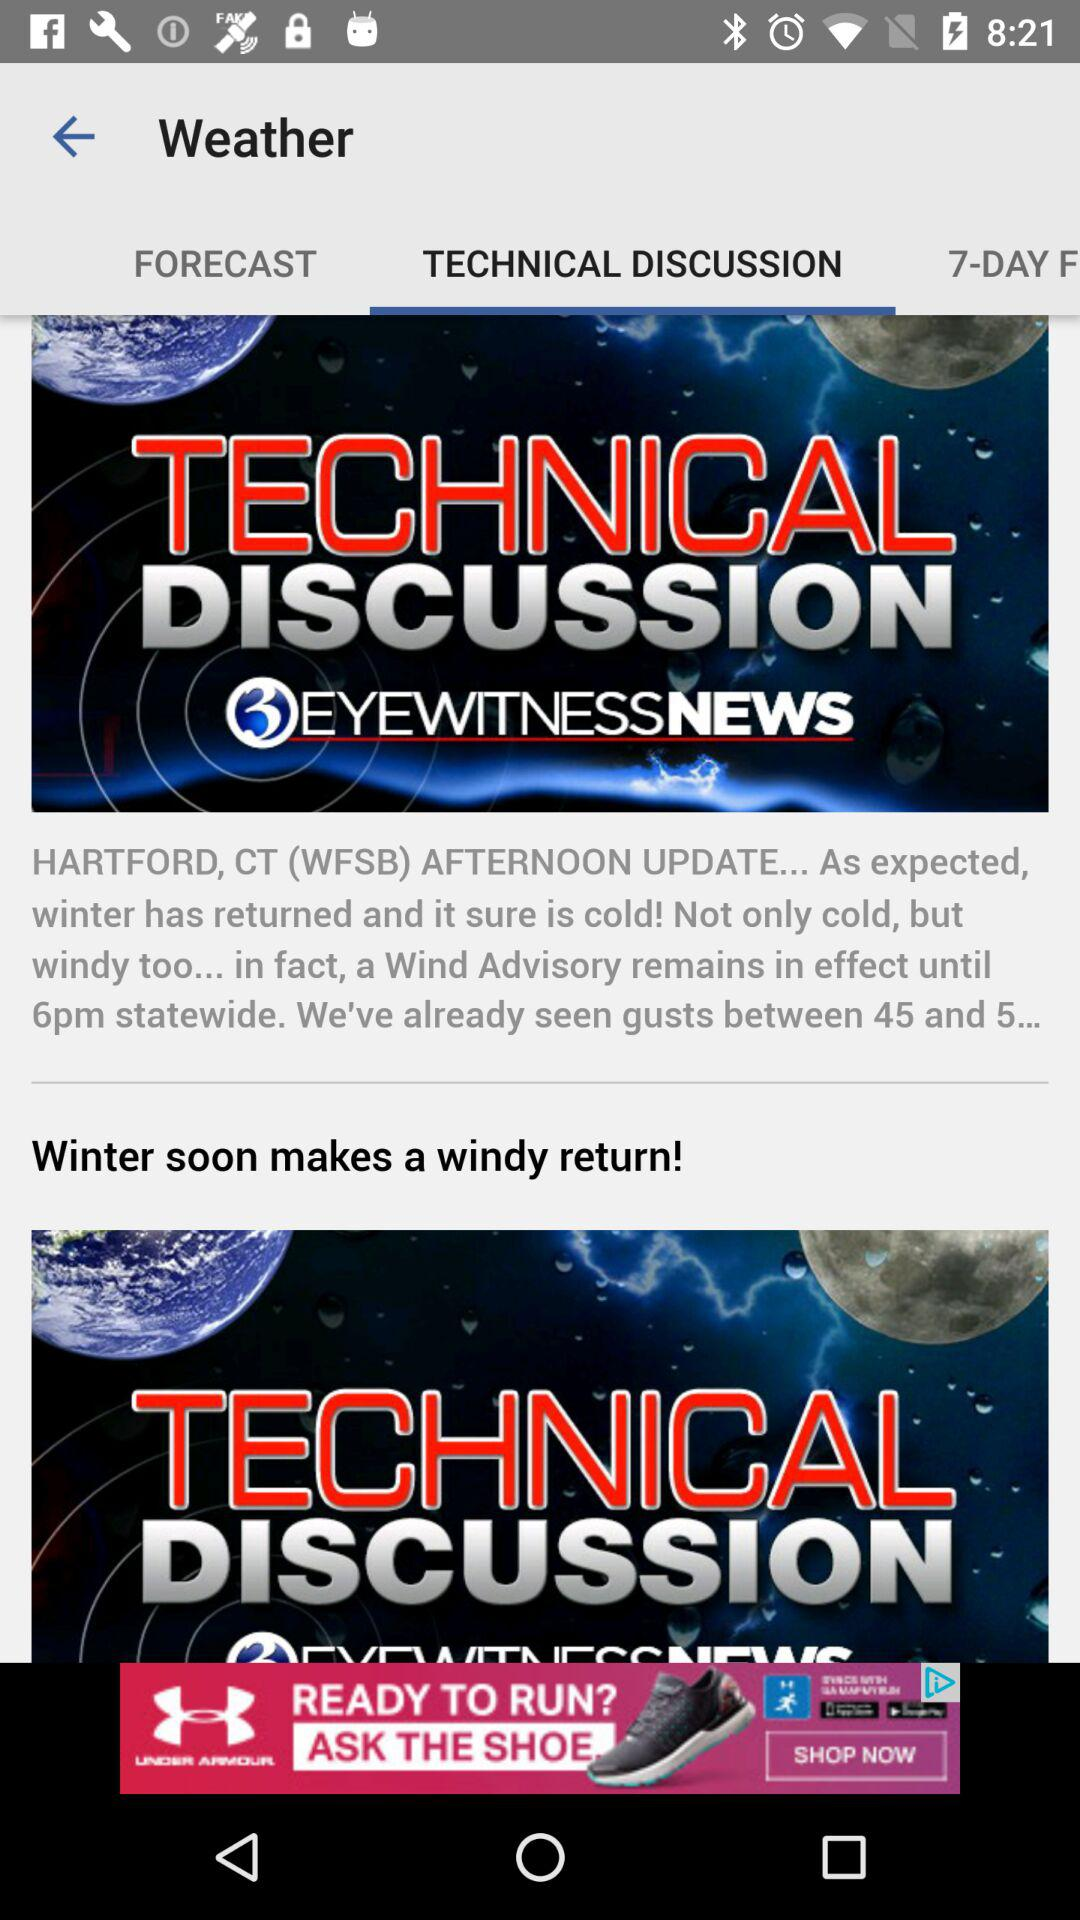How is the weather? The weather is cold and windy. 